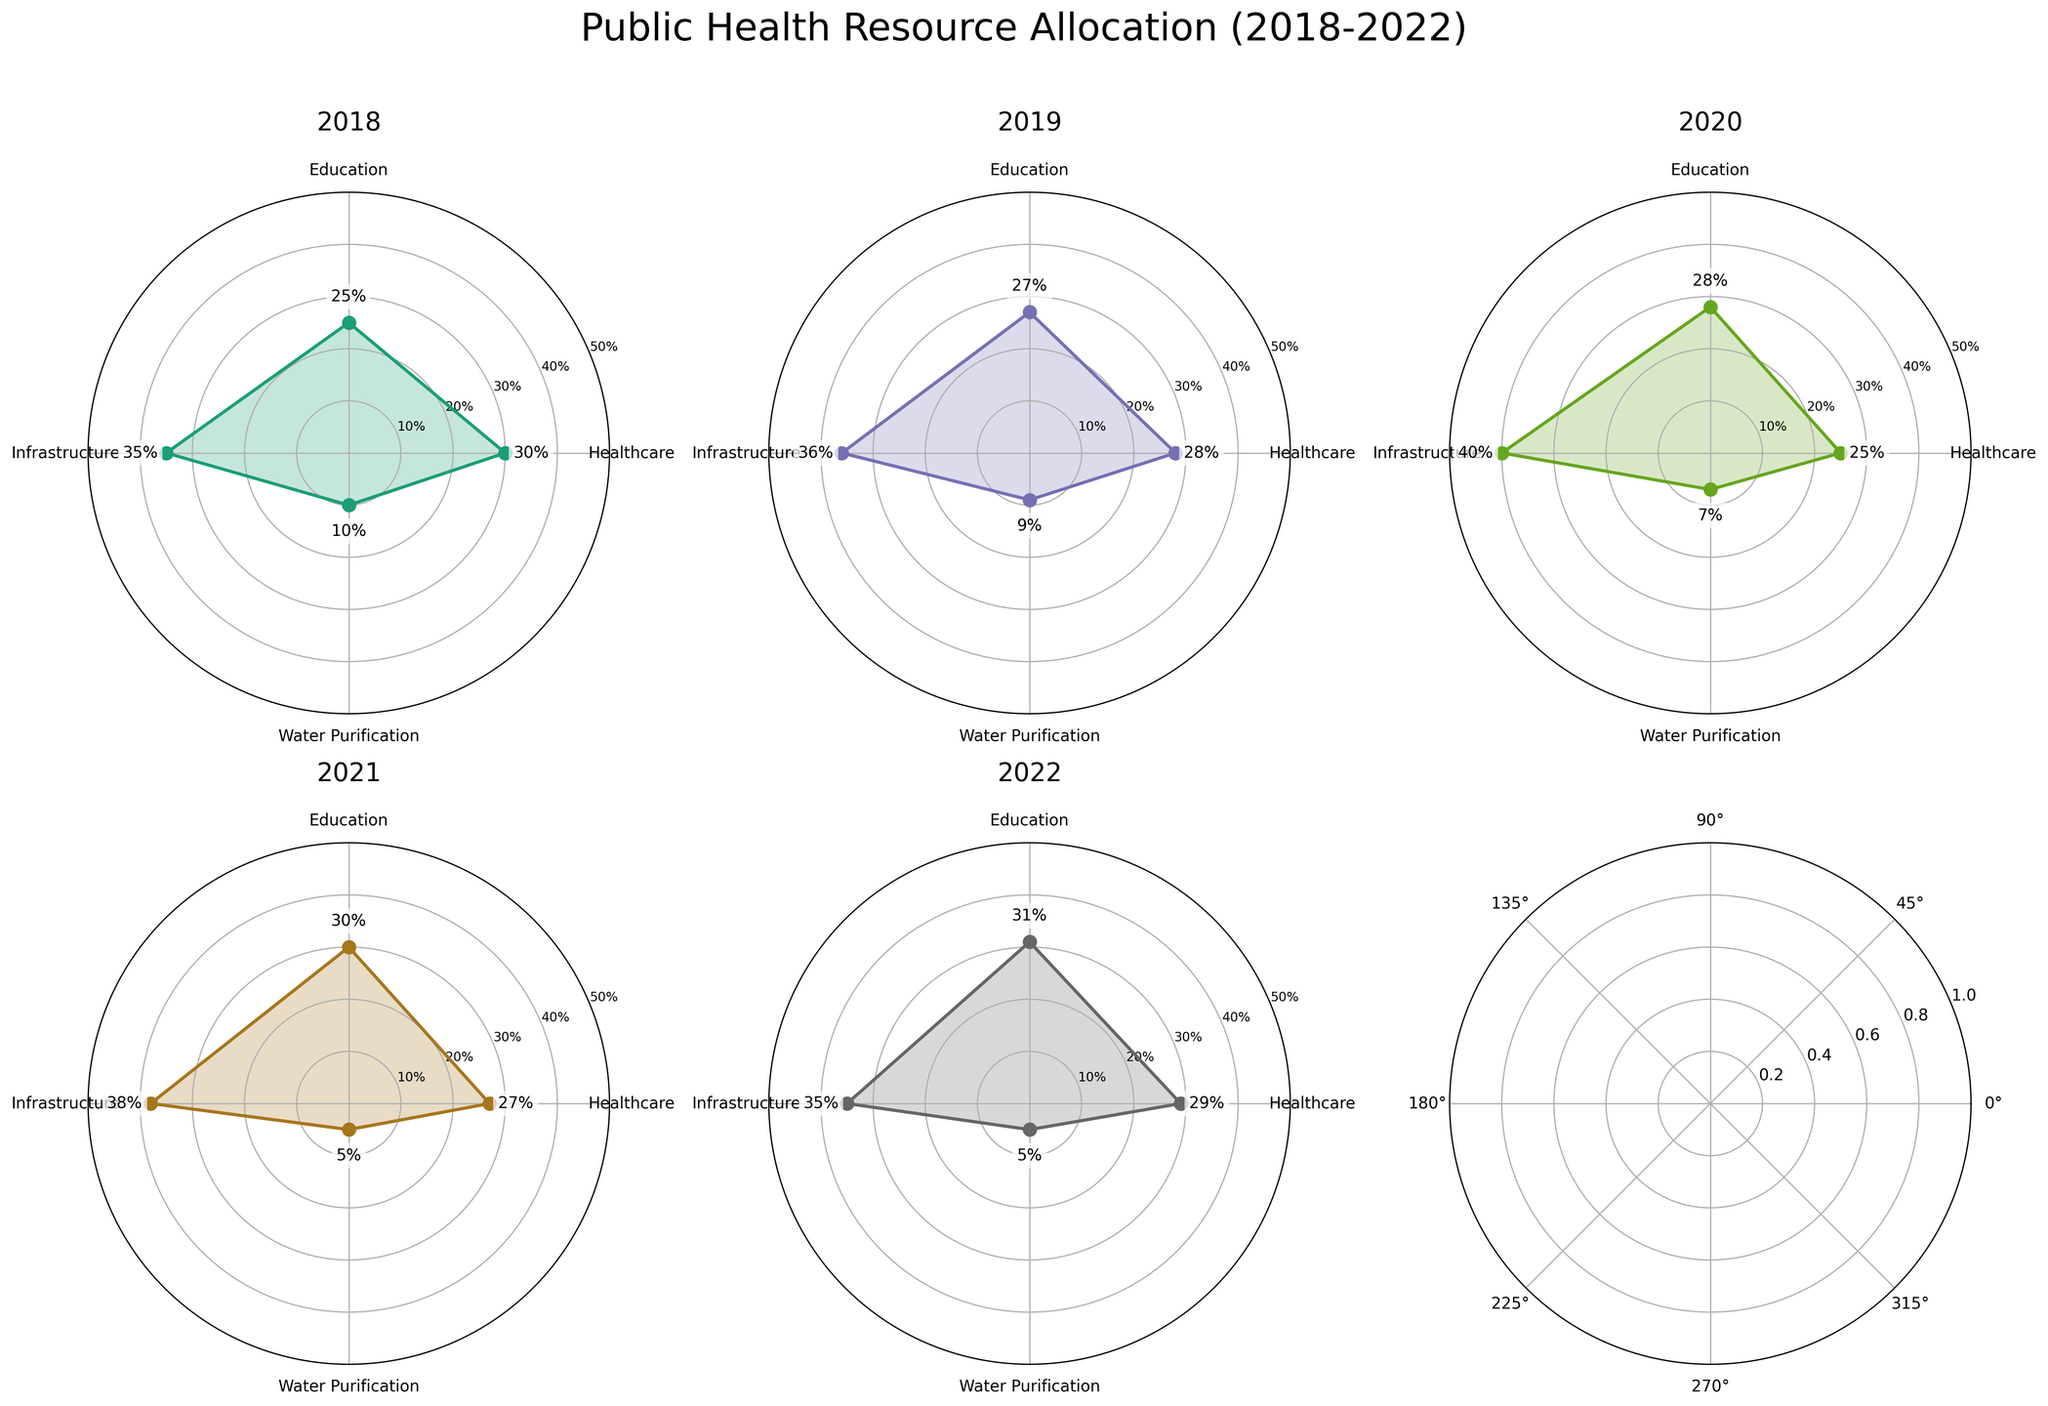What's the title of the figure? The title is located at the top of the figure and provides an overview of the data being visualized.
Answer: Public Health Resource Allocation (2018-2022) How many sectors are shown in each sub-plot? Each sub-plot represents the allocation across four sectors, visible on the radial axis.
Answer: Four sectors What are the sectors illustrated in the plots? The sectors can be identified from the labels on the radial axis of any sub-plot.
Answer: Healthcare, Education, Infrastructure, Water Purification Which year had the highest allocation for Education? Check each sub-plot's values for the Education sector, which can be found on the specific radial axis for each year.
Answer: 2022 How did the allocation for Water Purification change from 2018 to 2022? Observe the values for the Water Purification sector in the sub-plots for 2018 and 2022.
Answer: Decreased from 10% to 5% What is the difference in resource allocation for Healthcare between 2018 and 2020? Compare the values of Healthcare for 2018 and 2020 by looking at their sub-plots. Subtract 2020's allocation from 2018's.
Answer: 5% Which sector had the most significant reduction in allocation over the years? Look at the trends across the sub-plots for each sector and identify the one with the greatest decrease.
Answer: Water Purification What was the average allocation percentage for Infrastructure from 2018 to 2022? Sum the allocation percentages for Infrastructure across all years and divide by the number of years (5). (35+36+40+38+35)/5=36.8
Answer: 36.8% In which year was the allocation for Healthcare the lowest? Check each sub-plot's values for Healthcare and compare to find the minimum value.
Answer: 2020 Which sector consistently received more than 25% of the allocation every year? Go through each sub-plot and check which sector(s) had an allocation above 25% each year.
Answer: Infrastructure 